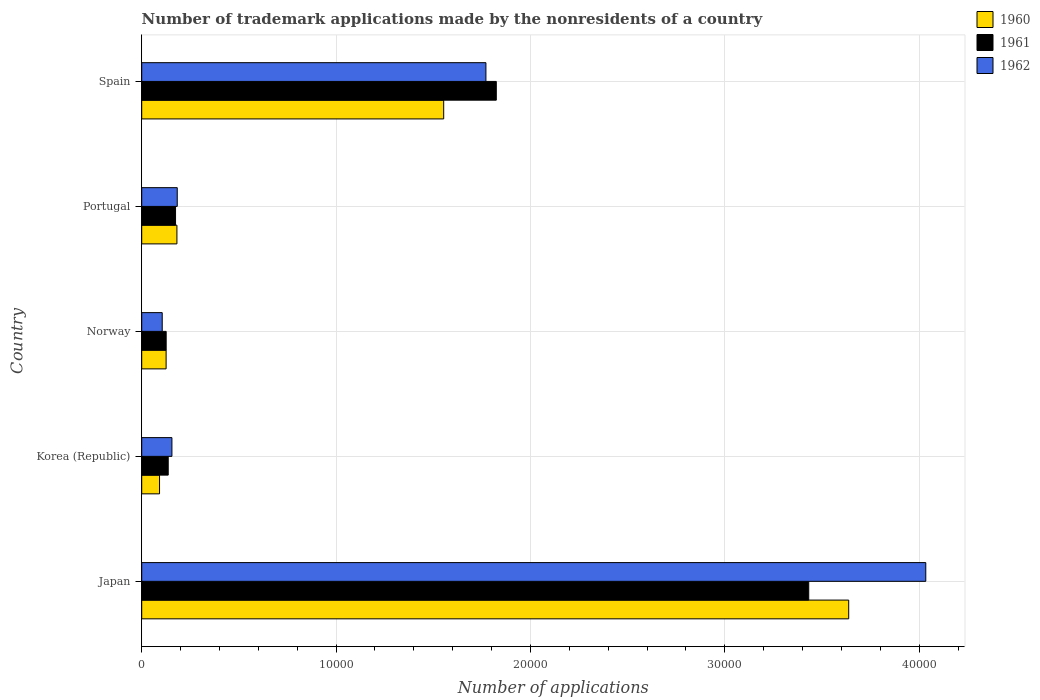How many different coloured bars are there?
Offer a very short reply. 3. How many groups of bars are there?
Offer a terse response. 5. Are the number of bars on each tick of the Y-axis equal?
Provide a short and direct response. Yes. How many bars are there on the 3rd tick from the top?
Provide a succinct answer. 3. How many bars are there on the 2nd tick from the bottom?
Keep it short and to the point. 3. In how many cases, is the number of bars for a given country not equal to the number of legend labels?
Give a very brief answer. 0. What is the number of trademark applications made by the nonresidents in 1962 in Spain?
Offer a terse response. 1.77e+04. Across all countries, what is the maximum number of trademark applications made by the nonresidents in 1960?
Offer a very short reply. 3.64e+04. Across all countries, what is the minimum number of trademark applications made by the nonresidents in 1962?
Ensure brevity in your answer.  1055. In which country was the number of trademark applications made by the nonresidents in 1962 minimum?
Keep it short and to the point. Norway. What is the total number of trademark applications made by the nonresidents in 1960 in the graph?
Give a very brief answer. 5.59e+04. What is the difference between the number of trademark applications made by the nonresidents in 1962 in Japan and that in Korea (Republic)?
Provide a succinct answer. 3.88e+04. What is the difference between the number of trademark applications made by the nonresidents in 1960 in Spain and the number of trademark applications made by the nonresidents in 1961 in Korea (Republic)?
Your response must be concise. 1.42e+04. What is the average number of trademark applications made by the nonresidents in 1962 per country?
Give a very brief answer. 1.25e+04. What is the difference between the number of trademark applications made by the nonresidents in 1961 and number of trademark applications made by the nonresidents in 1960 in Korea (Republic)?
Your response must be concise. 447. In how many countries, is the number of trademark applications made by the nonresidents in 1961 greater than 28000 ?
Keep it short and to the point. 1. What is the ratio of the number of trademark applications made by the nonresidents in 1961 in Japan to that in Portugal?
Your response must be concise. 19.72. What is the difference between the highest and the second highest number of trademark applications made by the nonresidents in 1962?
Your response must be concise. 2.26e+04. What is the difference between the highest and the lowest number of trademark applications made by the nonresidents in 1961?
Keep it short and to the point. 3.31e+04. Is the sum of the number of trademark applications made by the nonresidents in 1960 in Portugal and Spain greater than the maximum number of trademark applications made by the nonresidents in 1962 across all countries?
Make the answer very short. No. Is it the case that in every country, the sum of the number of trademark applications made by the nonresidents in 1962 and number of trademark applications made by the nonresidents in 1960 is greater than the number of trademark applications made by the nonresidents in 1961?
Make the answer very short. Yes. How many bars are there?
Make the answer very short. 15. How many countries are there in the graph?
Offer a very short reply. 5. Are the values on the major ticks of X-axis written in scientific E-notation?
Make the answer very short. No. Where does the legend appear in the graph?
Your answer should be very brief. Top right. How many legend labels are there?
Provide a short and direct response. 3. What is the title of the graph?
Make the answer very short. Number of trademark applications made by the nonresidents of a country. What is the label or title of the X-axis?
Your answer should be very brief. Number of applications. What is the Number of applications of 1960 in Japan?
Provide a succinct answer. 3.64e+04. What is the Number of applications in 1961 in Japan?
Keep it short and to the point. 3.43e+04. What is the Number of applications of 1962 in Japan?
Provide a succinct answer. 4.03e+04. What is the Number of applications of 1960 in Korea (Republic)?
Make the answer very short. 916. What is the Number of applications of 1961 in Korea (Republic)?
Give a very brief answer. 1363. What is the Number of applications of 1962 in Korea (Republic)?
Your response must be concise. 1554. What is the Number of applications of 1960 in Norway?
Your answer should be compact. 1255. What is the Number of applications of 1961 in Norway?
Give a very brief answer. 1258. What is the Number of applications of 1962 in Norway?
Your answer should be compact. 1055. What is the Number of applications in 1960 in Portugal?
Keep it short and to the point. 1811. What is the Number of applications in 1961 in Portugal?
Your answer should be compact. 1740. What is the Number of applications of 1962 in Portugal?
Offer a terse response. 1828. What is the Number of applications in 1960 in Spain?
Give a very brief answer. 1.55e+04. What is the Number of applications in 1961 in Spain?
Your response must be concise. 1.82e+04. What is the Number of applications of 1962 in Spain?
Your response must be concise. 1.77e+04. Across all countries, what is the maximum Number of applications in 1960?
Provide a succinct answer. 3.64e+04. Across all countries, what is the maximum Number of applications in 1961?
Keep it short and to the point. 3.43e+04. Across all countries, what is the maximum Number of applications in 1962?
Make the answer very short. 4.03e+04. Across all countries, what is the minimum Number of applications of 1960?
Keep it short and to the point. 916. Across all countries, what is the minimum Number of applications of 1961?
Your response must be concise. 1258. Across all countries, what is the minimum Number of applications of 1962?
Give a very brief answer. 1055. What is the total Number of applications of 1960 in the graph?
Provide a short and direct response. 5.59e+04. What is the total Number of applications of 1961 in the graph?
Offer a very short reply. 5.69e+04. What is the total Number of applications of 1962 in the graph?
Keep it short and to the point. 6.25e+04. What is the difference between the Number of applications of 1960 in Japan and that in Korea (Republic)?
Provide a succinct answer. 3.55e+04. What is the difference between the Number of applications in 1961 in Japan and that in Korea (Republic)?
Your response must be concise. 3.30e+04. What is the difference between the Number of applications in 1962 in Japan and that in Korea (Republic)?
Ensure brevity in your answer.  3.88e+04. What is the difference between the Number of applications in 1960 in Japan and that in Norway?
Ensure brevity in your answer.  3.51e+04. What is the difference between the Number of applications in 1961 in Japan and that in Norway?
Your response must be concise. 3.31e+04. What is the difference between the Number of applications of 1962 in Japan and that in Norway?
Your answer should be very brief. 3.93e+04. What is the difference between the Number of applications of 1960 in Japan and that in Portugal?
Your response must be concise. 3.46e+04. What is the difference between the Number of applications of 1961 in Japan and that in Portugal?
Give a very brief answer. 3.26e+04. What is the difference between the Number of applications in 1962 in Japan and that in Portugal?
Make the answer very short. 3.85e+04. What is the difference between the Number of applications of 1960 in Japan and that in Spain?
Give a very brief answer. 2.08e+04. What is the difference between the Number of applications in 1961 in Japan and that in Spain?
Keep it short and to the point. 1.61e+04. What is the difference between the Number of applications in 1962 in Japan and that in Spain?
Provide a succinct answer. 2.26e+04. What is the difference between the Number of applications in 1960 in Korea (Republic) and that in Norway?
Provide a succinct answer. -339. What is the difference between the Number of applications of 1961 in Korea (Republic) and that in Norway?
Your answer should be very brief. 105. What is the difference between the Number of applications in 1962 in Korea (Republic) and that in Norway?
Offer a terse response. 499. What is the difference between the Number of applications of 1960 in Korea (Republic) and that in Portugal?
Provide a succinct answer. -895. What is the difference between the Number of applications of 1961 in Korea (Republic) and that in Portugal?
Make the answer very short. -377. What is the difference between the Number of applications of 1962 in Korea (Republic) and that in Portugal?
Give a very brief answer. -274. What is the difference between the Number of applications of 1960 in Korea (Republic) and that in Spain?
Provide a succinct answer. -1.46e+04. What is the difference between the Number of applications in 1961 in Korea (Republic) and that in Spain?
Keep it short and to the point. -1.69e+04. What is the difference between the Number of applications of 1962 in Korea (Republic) and that in Spain?
Provide a succinct answer. -1.62e+04. What is the difference between the Number of applications of 1960 in Norway and that in Portugal?
Provide a succinct answer. -556. What is the difference between the Number of applications in 1961 in Norway and that in Portugal?
Give a very brief answer. -482. What is the difference between the Number of applications in 1962 in Norway and that in Portugal?
Provide a succinct answer. -773. What is the difference between the Number of applications in 1960 in Norway and that in Spain?
Give a very brief answer. -1.43e+04. What is the difference between the Number of applications in 1961 in Norway and that in Spain?
Offer a very short reply. -1.70e+04. What is the difference between the Number of applications in 1962 in Norway and that in Spain?
Your answer should be very brief. -1.67e+04. What is the difference between the Number of applications of 1960 in Portugal and that in Spain?
Your response must be concise. -1.37e+04. What is the difference between the Number of applications of 1961 in Portugal and that in Spain?
Give a very brief answer. -1.65e+04. What is the difference between the Number of applications in 1962 in Portugal and that in Spain?
Make the answer very short. -1.59e+04. What is the difference between the Number of applications in 1960 in Japan and the Number of applications in 1961 in Korea (Republic)?
Your answer should be compact. 3.50e+04. What is the difference between the Number of applications of 1960 in Japan and the Number of applications of 1962 in Korea (Republic)?
Give a very brief answer. 3.48e+04. What is the difference between the Number of applications in 1961 in Japan and the Number of applications in 1962 in Korea (Republic)?
Make the answer very short. 3.28e+04. What is the difference between the Number of applications of 1960 in Japan and the Number of applications of 1961 in Norway?
Your answer should be very brief. 3.51e+04. What is the difference between the Number of applications in 1960 in Japan and the Number of applications in 1962 in Norway?
Give a very brief answer. 3.53e+04. What is the difference between the Number of applications of 1961 in Japan and the Number of applications of 1962 in Norway?
Keep it short and to the point. 3.33e+04. What is the difference between the Number of applications in 1960 in Japan and the Number of applications in 1961 in Portugal?
Make the answer very short. 3.46e+04. What is the difference between the Number of applications in 1960 in Japan and the Number of applications in 1962 in Portugal?
Your answer should be compact. 3.45e+04. What is the difference between the Number of applications of 1961 in Japan and the Number of applications of 1962 in Portugal?
Give a very brief answer. 3.25e+04. What is the difference between the Number of applications of 1960 in Japan and the Number of applications of 1961 in Spain?
Provide a succinct answer. 1.81e+04. What is the difference between the Number of applications in 1960 in Japan and the Number of applications in 1962 in Spain?
Provide a short and direct response. 1.87e+04. What is the difference between the Number of applications in 1961 in Japan and the Number of applications in 1962 in Spain?
Provide a short and direct response. 1.66e+04. What is the difference between the Number of applications in 1960 in Korea (Republic) and the Number of applications in 1961 in Norway?
Your answer should be compact. -342. What is the difference between the Number of applications in 1960 in Korea (Republic) and the Number of applications in 1962 in Norway?
Ensure brevity in your answer.  -139. What is the difference between the Number of applications of 1961 in Korea (Republic) and the Number of applications of 1962 in Norway?
Offer a terse response. 308. What is the difference between the Number of applications of 1960 in Korea (Republic) and the Number of applications of 1961 in Portugal?
Offer a very short reply. -824. What is the difference between the Number of applications in 1960 in Korea (Republic) and the Number of applications in 1962 in Portugal?
Your answer should be very brief. -912. What is the difference between the Number of applications of 1961 in Korea (Republic) and the Number of applications of 1962 in Portugal?
Provide a short and direct response. -465. What is the difference between the Number of applications of 1960 in Korea (Republic) and the Number of applications of 1961 in Spain?
Your answer should be compact. -1.73e+04. What is the difference between the Number of applications in 1960 in Korea (Republic) and the Number of applications in 1962 in Spain?
Keep it short and to the point. -1.68e+04. What is the difference between the Number of applications in 1961 in Korea (Republic) and the Number of applications in 1962 in Spain?
Your answer should be very brief. -1.63e+04. What is the difference between the Number of applications of 1960 in Norway and the Number of applications of 1961 in Portugal?
Your answer should be compact. -485. What is the difference between the Number of applications of 1960 in Norway and the Number of applications of 1962 in Portugal?
Provide a short and direct response. -573. What is the difference between the Number of applications of 1961 in Norway and the Number of applications of 1962 in Portugal?
Keep it short and to the point. -570. What is the difference between the Number of applications of 1960 in Norway and the Number of applications of 1961 in Spain?
Your response must be concise. -1.70e+04. What is the difference between the Number of applications in 1960 in Norway and the Number of applications in 1962 in Spain?
Offer a very short reply. -1.65e+04. What is the difference between the Number of applications in 1961 in Norway and the Number of applications in 1962 in Spain?
Your answer should be very brief. -1.65e+04. What is the difference between the Number of applications of 1960 in Portugal and the Number of applications of 1961 in Spain?
Ensure brevity in your answer.  -1.64e+04. What is the difference between the Number of applications of 1960 in Portugal and the Number of applications of 1962 in Spain?
Your answer should be compact. -1.59e+04. What is the difference between the Number of applications of 1961 in Portugal and the Number of applications of 1962 in Spain?
Keep it short and to the point. -1.60e+04. What is the average Number of applications in 1960 per country?
Offer a very short reply. 1.12e+04. What is the average Number of applications of 1961 per country?
Ensure brevity in your answer.  1.14e+04. What is the average Number of applications of 1962 per country?
Your response must be concise. 1.25e+04. What is the difference between the Number of applications in 1960 and Number of applications in 1961 in Japan?
Your response must be concise. 2057. What is the difference between the Number of applications of 1960 and Number of applications of 1962 in Japan?
Your response must be concise. -3966. What is the difference between the Number of applications in 1961 and Number of applications in 1962 in Japan?
Make the answer very short. -6023. What is the difference between the Number of applications in 1960 and Number of applications in 1961 in Korea (Republic)?
Your answer should be compact. -447. What is the difference between the Number of applications in 1960 and Number of applications in 1962 in Korea (Republic)?
Ensure brevity in your answer.  -638. What is the difference between the Number of applications in 1961 and Number of applications in 1962 in Korea (Republic)?
Make the answer very short. -191. What is the difference between the Number of applications in 1961 and Number of applications in 1962 in Norway?
Make the answer very short. 203. What is the difference between the Number of applications in 1961 and Number of applications in 1962 in Portugal?
Your answer should be very brief. -88. What is the difference between the Number of applications in 1960 and Number of applications in 1961 in Spain?
Make the answer very short. -2707. What is the difference between the Number of applications in 1960 and Number of applications in 1962 in Spain?
Offer a terse response. -2173. What is the difference between the Number of applications of 1961 and Number of applications of 1962 in Spain?
Your answer should be very brief. 534. What is the ratio of the Number of applications in 1960 in Japan to that in Korea (Republic)?
Make the answer very short. 39.71. What is the ratio of the Number of applications of 1961 in Japan to that in Korea (Republic)?
Give a very brief answer. 25.18. What is the ratio of the Number of applications of 1962 in Japan to that in Korea (Republic)?
Offer a terse response. 25.96. What is the ratio of the Number of applications of 1960 in Japan to that in Norway?
Your response must be concise. 28.99. What is the ratio of the Number of applications of 1961 in Japan to that in Norway?
Your answer should be very brief. 27.28. What is the ratio of the Number of applications in 1962 in Japan to that in Norway?
Your answer should be compact. 38.24. What is the ratio of the Number of applications of 1960 in Japan to that in Portugal?
Give a very brief answer. 20.09. What is the ratio of the Number of applications in 1961 in Japan to that in Portugal?
Ensure brevity in your answer.  19.72. What is the ratio of the Number of applications of 1962 in Japan to that in Portugal?
Give a very brief answer. 22.07. What is the ratio of the Number of applications of 1960 in Japan to that in Spain?
Make the answer very short. 2.34. What is the ratio of the Number of applications of 1961 in Japan to that in Spain?
Ensure brevity in your answer.  1.88. What is the ratio of the Number of applications of 1962 in Japan to that in Spain?
Provide a succinct answer. 2.28. What is the ratio of the Number of applications of 1960 in Korea (Republic) to that in Norway?
Offer a very short reply. 0.73. What is the ratio of the Number of applications of 1961 in Korea (Republic) to that in Norway?
Keep it short and to the point. 1.08. What is the ratio of the Number of applications of 1962 in Korea (Republic) to that in Norway?
Make the answer very short. 1.47. What is the ratio of the Number of applications in 1960 in Korea (Republic) to that in Portugal?
Keep it short and to the point. 0.51. What is the ratio of the Number of applications of 1961 in Korea (Republic) to that in Portugal?
Make the answer very short. 0.78. What is the ratio of the Number of applications of 1962 in Korea (Republic) to that in Portugal?
Your answer should be compact. 0.85. What is the ratio of the Number of applications in 1960 in Korea (Republic) to that in Spain?
Offer a very short reply. 0.06. What is the ratio of the Number of applications of 1961 in Korea (Republic) to that in Spain?
Keep it short and to the point. 0.07. What is the ratio of the Number of applications of 1962 in Korea (Republic) to that in Spain?
Offer a terse response. 0.09. What is the ratio of the Number of applications of 1960 in Norway to that in Portugal?
Your response must be concise. 0.69. What is the ratio of the Number of applications in 1961 in Norway to that in Portugal?
Offer a terse response. 0.72. What is the ratio of the Number of applications of 1962 in Norway to that in Portugal?
Give a very brief answer. 0.58. What is the ratio of the Number of applications in 1960 in Norway to that in Spain?
Provide a succinct answer. 0.08. What is the ratio of the Number of applications in 1961 in Norway to that in Spain?
Your answer should be compact. 0.07. What is the ratio of the Number of applications in 1962 in Norway to that in Spain?
Keep it short and to the point. 0.06. What is the ratio of the Number of applications of 1960 in Portugal to that in Spain?
Your answer should be very brief. 0.12. What is the ratio of the Number of applications in 1961 in Portugal to that in Spain?
Offer a very short reply. 0.1. What is the ratio of the Number of applications in 1962 in Portugal to that in Spain?
Keep it short and to the point. 0.1. What is the difference between the highest and the second highest Number of applications in 1960?
Your response must be concise. 2.08e+04. What is the difference between the highest and the second highest Number of applications of 1961?
Provide a short and direct response. 1.61e+04. What is the difference between the highest and the second highest Number of applications of 1962?
Provide a succinct answer. 2.26e+04. What is the difference between the highest and the lowest Number of applications of 1960?
Your response must be concise. 3.55e+04. What is the difference between the highest and the lowest Number of applications in 1961?
Give a very brief answer. 3.31e+04. What is the difference between the highest and the lowest Number of applications of 1962?
Make the answer very short. 3.93e+04. 